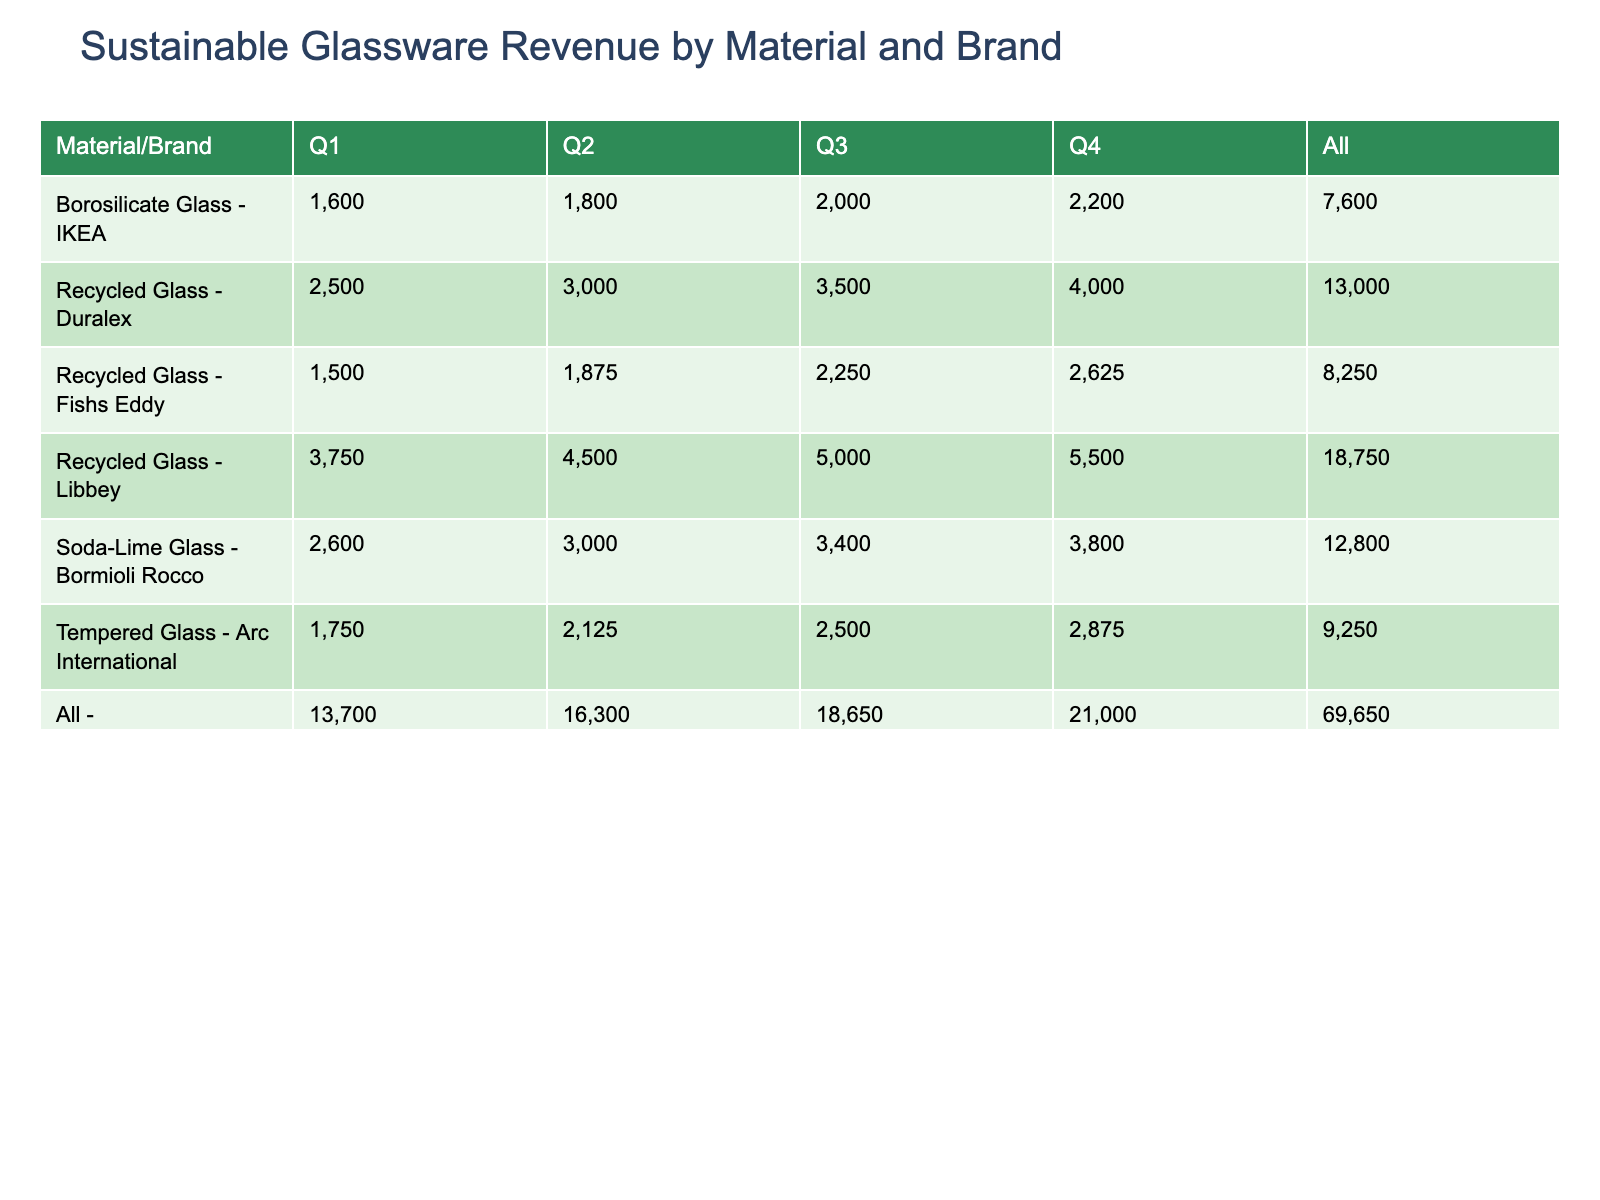What material and brand generated the highest revenue in Q2? To find this, examine the table under Q2 for each material and brand combination. The entry for Recycled Glass by Libbey with 4500 is the highest among all, therefore, Libbey Recycled Glass generated the most revenue in Q2.
Answer: Libbey Recycled Glass What is the total revenue generated from Soda-Lime Glass across all quarters? The total revenue for Soda-Lime Glass is found by summing the revenues for Bormioli Rocco (2600 + 3000 + 3400 + 3800) = 12800.
Answer: 12800 Did Duralex achieve greater revenue in Q3 compared to Q4? For Duralex, Q3 revenue is 3500 and Q4 revenue is 4000. Since 3500 is less than 4000, the answer is no.
Answer: No What was the average revenue of Tempered Glass across all quarters? The revenue for Tempered Glass by Arc International is (1750 + 2125 + 2500 + 2875) = 9250 for four quarters. Dividing this total revenue by 4 gives an average of 9250 / 4 = 2312.5.
Answer: 2312.5 Which material had the lowest total units sold across all quarters? First, find the total units sold for each material: Recycled Glass (150 + 180 + 200 + 220 + 100 + 120 + 140 + 160 + 60 + 75 + 90 + 105 = 1690), Borosilicate Glass (80 + 90 + 100 + 110 = 380), Soda-Lime Glass (130 + 150 + 170 + 190 = 640), and Tempered Glass (70 + 85 + 100 + 115 = 370). The lowest is Tempered Glass with a total of 370 units sold.
Answer: Tempered Glass 